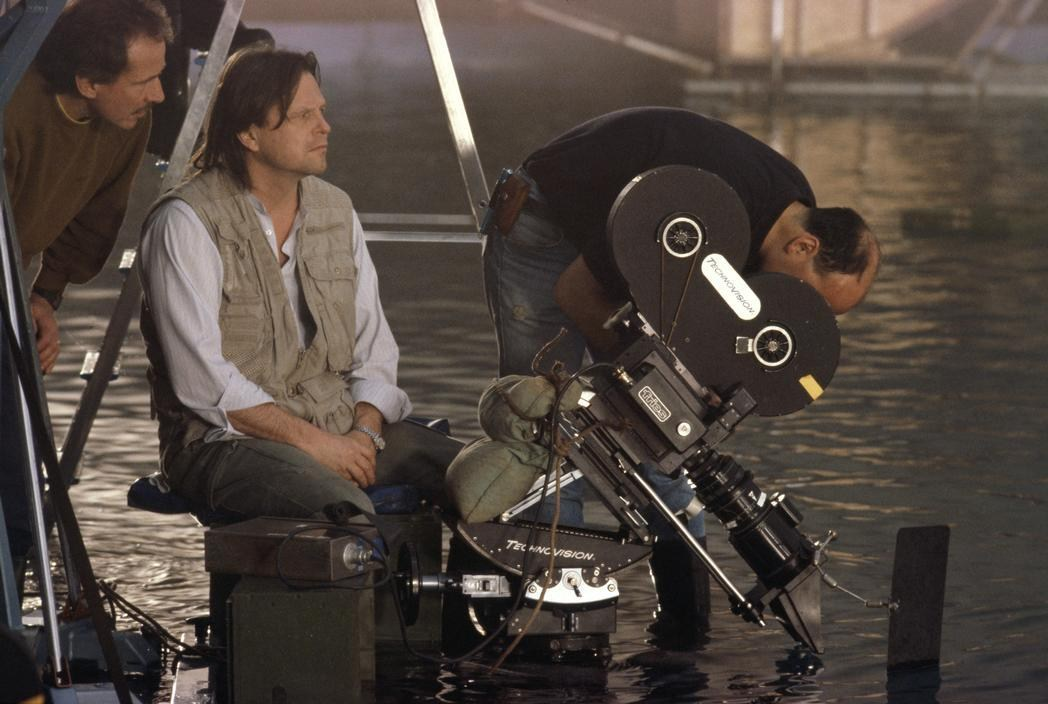Describe what could happen in this scene. In this scene, the characters might be attempting a dangerous crossing or escape through a flooded area. The camera being so close to the water implies that the action will be intense and immediate, possibly involving the actors struggling against the current, dealing with floating debris, or facing natural elements like heavy rain or rising water levels. There may be a rescue operation where a character is pulled from the water, adding to the suspense and drama. The reflective surfaces indicate that the cinematography will play a big role in creating a dramatic and visually stunning sequence. What could be a creative and unexpected twist for this scene? A creative and unexpected twist for this scene could be the discovery of an ancient underwater city or archaeological site as the characters navigate the flooded area. Imagine the tension and awe as the characters stumble upon the remnants of a lost civilization, their torchlights illuminating intricate carvings and relics beneath the murky waters. This twist would not only add an element of wonder and historical intrigue but also open up a new storyline involving the mysteries and dangers of uncovering ancient secrets. 